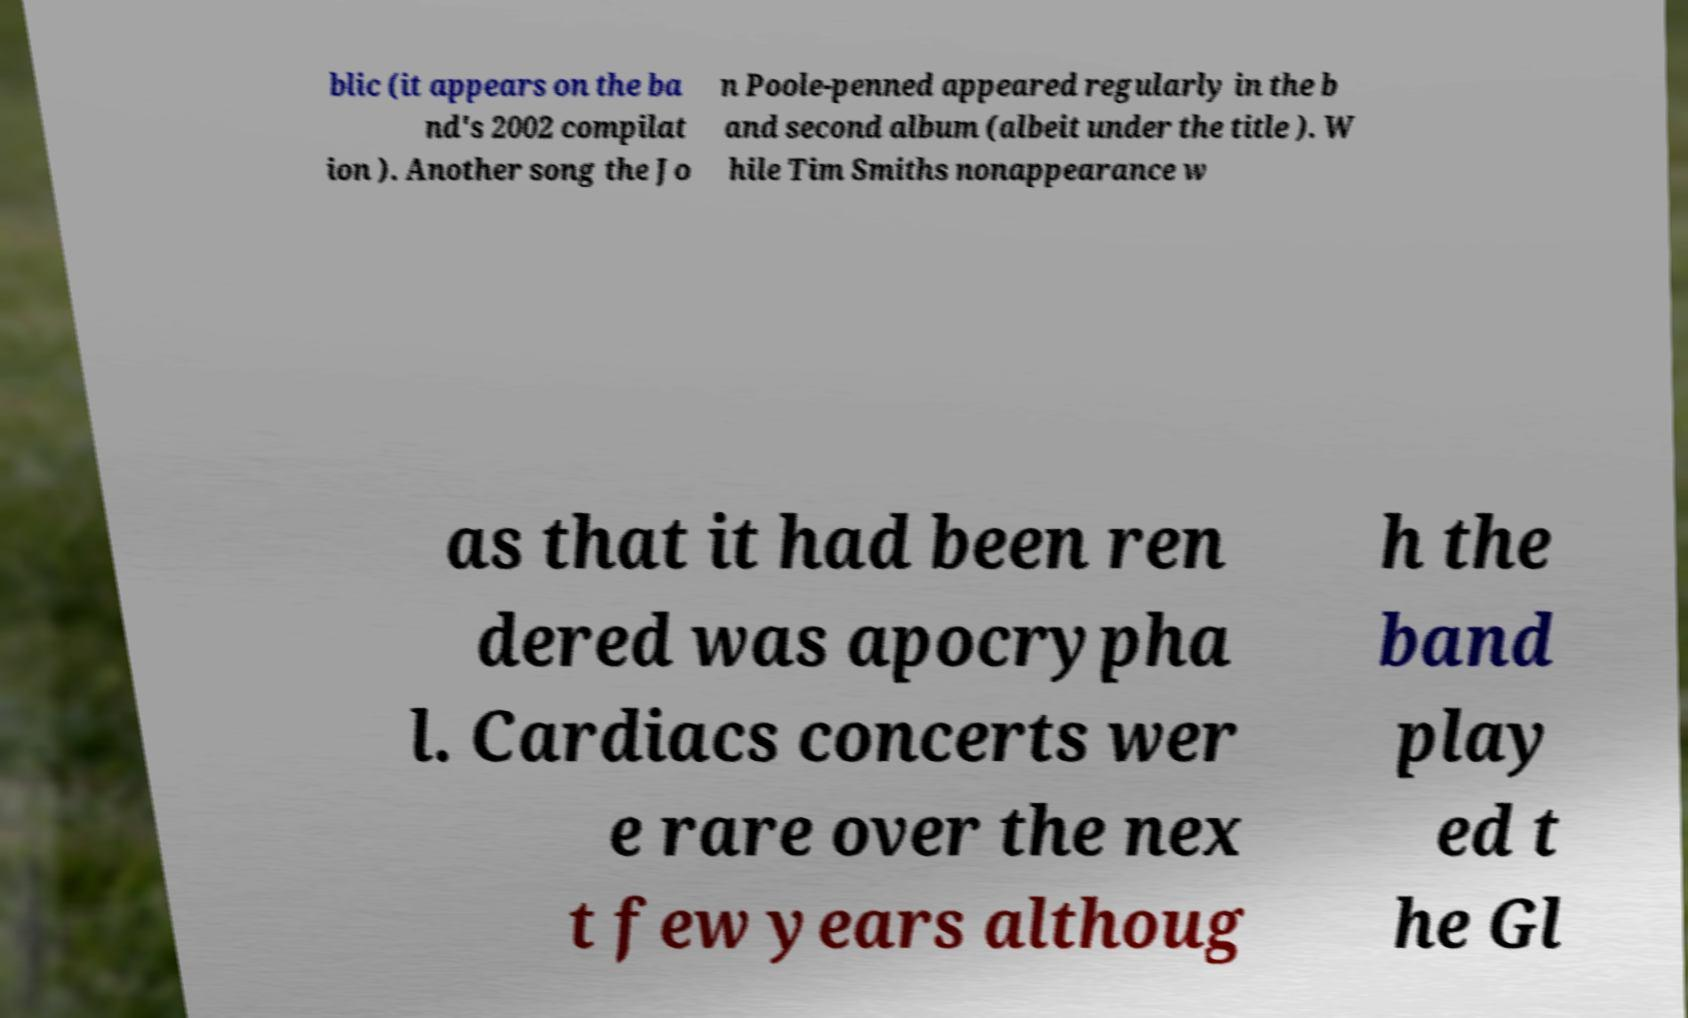I need the written content from this picture converted into text. Can you do that? blic (it appears on the ba nd's 2002 compilat ion ). Another song the Jo n Poole-penned appeared regularly in the b and second album (albeit under the title ). W hile Tim Smiths nonappearance w as that it had been ren dered was apocrypha l. Cardiacs concerts wer e rare over the nex t few years althoug h the band play ed t he Gl 